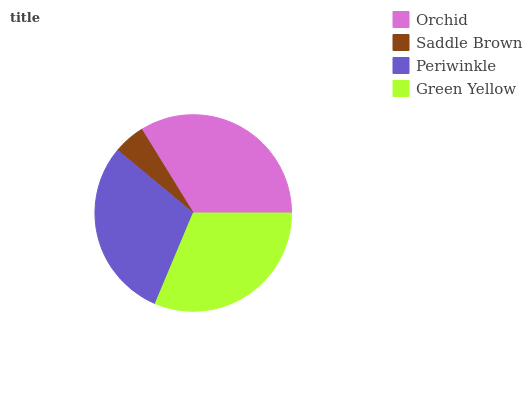Is Saddle Brown the minimum?
Answer yes or no. Yes. Is Orchid the maximum?
Answer yes or no. Yes. Is Periwinkle the minimum?
Answer yes or no. No. Is Periwinkle the maximum?
Answer yes or no. No. Is Periwinkle greater than Saddle Brown?
Answer yes or no. Yes. Is Saddle Brown less than Periwinkle?
Answer yes or no. Yes. Is Saddle Brown greater than Periwinkle?
Answer yes or no. No. Is Periwinkle less than Saddle Brown?
Answer yes or no. No. Is Green Yellow the high median?
Answer yes or no. Yes. Is Periwinkle the low median?
Answer yes or no. Yes. Is Periwinkle the high median?
Answer yes or no. No. Is Saddle Brown the low median?
Answer yes or no. No. 